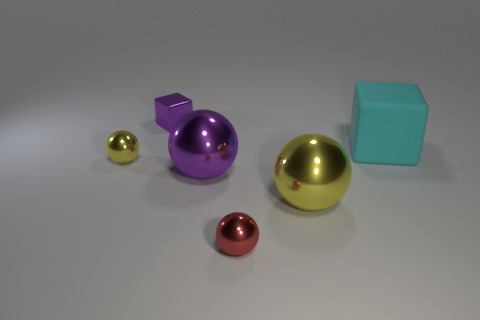How many other things are made of the same material as the cyan block? Based on the image, it is difficult to determine with absolute certainty the materials of each object. However, the cyan block appears to be made of a matte material, possibly plastic, and there are no other objects in the image with quite the same texture or material finish. Therefore, a more informative answer would be: 'While it's not possible to conclusively determine each material from visual inspection alone, there are no other objects that clearly share the same material characteristics as the cyan block.' 